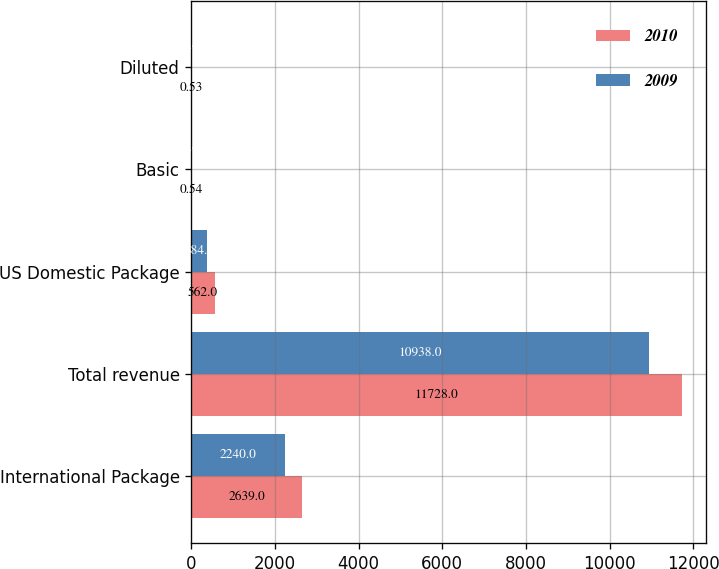Convert chart to OTSL. <chart><loc_0><loc_0><loc_500><loc_500><stacked_bar_chart><ecel><fcel>International Package<fcel>Total revenue<fcel>US Domestic Package<fcel>Basic<fcel>Diluted<nl><fcel>2010<fcel>2639<fcel>11728<fcel>562<fcel>0.54<fcel>0.53<nl><fcel>2009<fcel>2240<fcel>10938<fcel>384<fcel>0.4<fcel>0.4<nl></chart> 